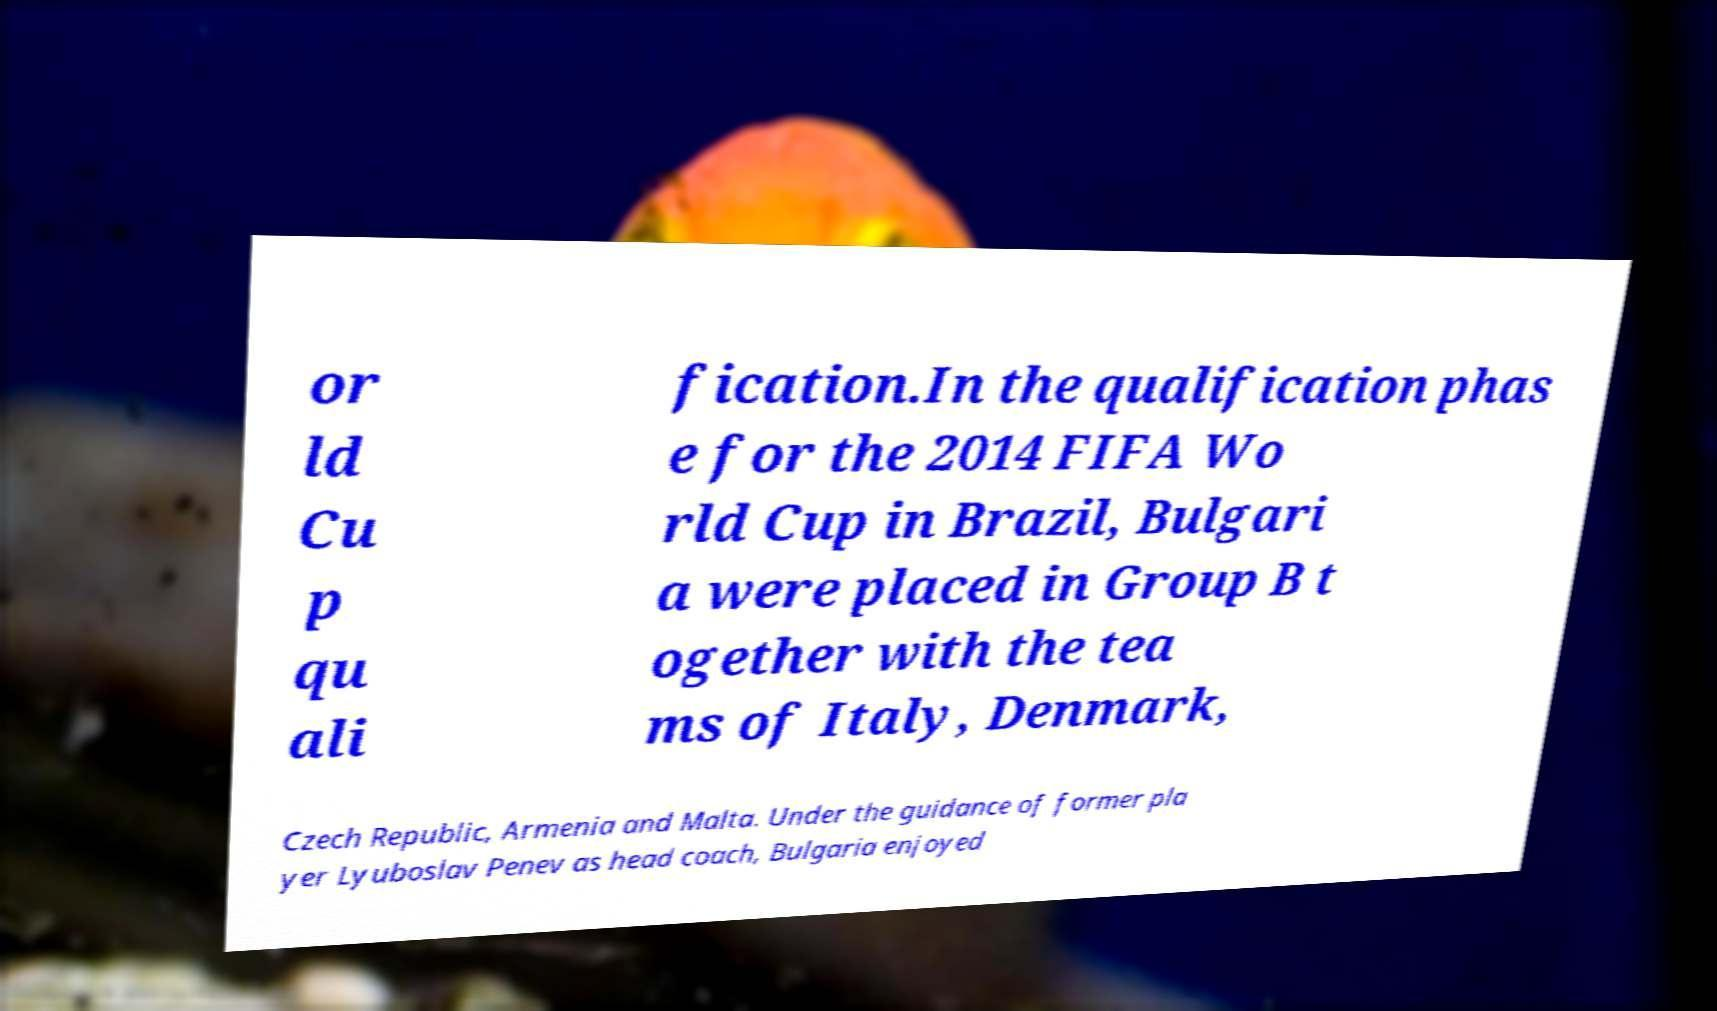What messages or text are displayed in this image? I need them in a readable, typed format. or ld Cu p qu ali fication.In the qualification phas e for the 2014 FIFA Wo rld Cup in Brazil, Bulgari a were placed in Group B t ogether with the tea ms of Italy, Denmark, Czech Republic, Armenia and Malta. Under the guidance of former pla yer Lyuboslav Penev as head coach, Bulgaria enjoyed 